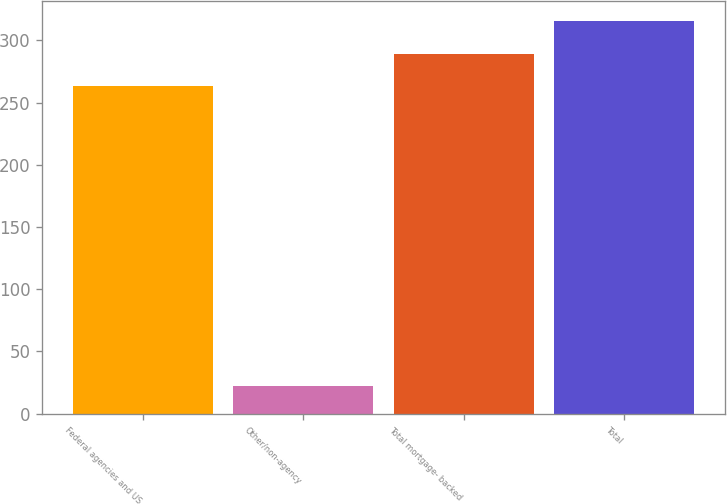Convert chart to OTSL. <chart><loc_0><loc_0><loc_500><loc_500><bar_chart><fcel>Federal agencies and US<fcel>Other/non-agency<fcel>Total mortgage- backed<fcel>Total<nl><fcel>263<fcel>22<fcel>289.4<fcel>315.8<nl></chart> 